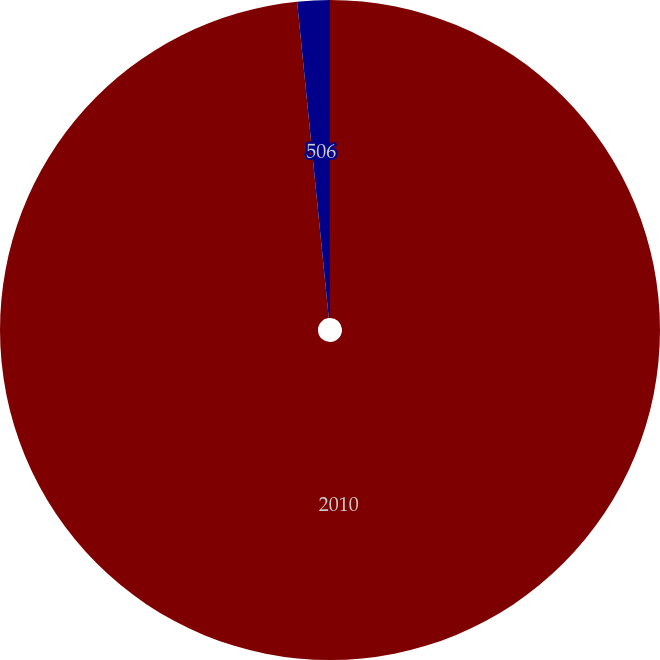Convert chart to OTSL. <chart><loc_0><loc_0><loc_500><loc_500><pie_chart><fcel>2010<fcel>506<nl><fcel>98.41%<fcel>1.59%<nl></chart> 